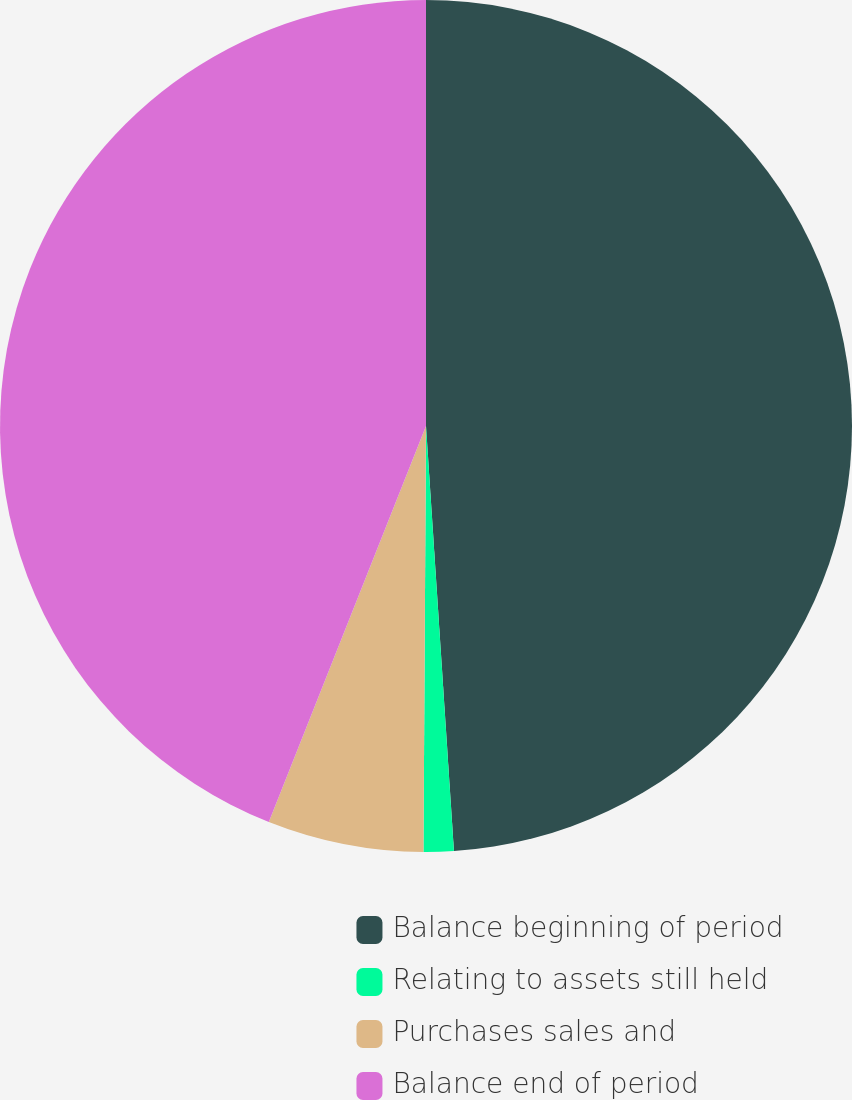Convert chart to OTSL. <chart><loc_0><loc_0><loc_500><loc_500><pie_chart><fcel>Balance beginning of period<fcel>Relating to assets still held<fcel>Purchases sales and<fcel>Balance end of period<nl><fcel>48.96%<fcel>1.14%<fcel>5.92%<fcel>43.99%<nl></chart> 